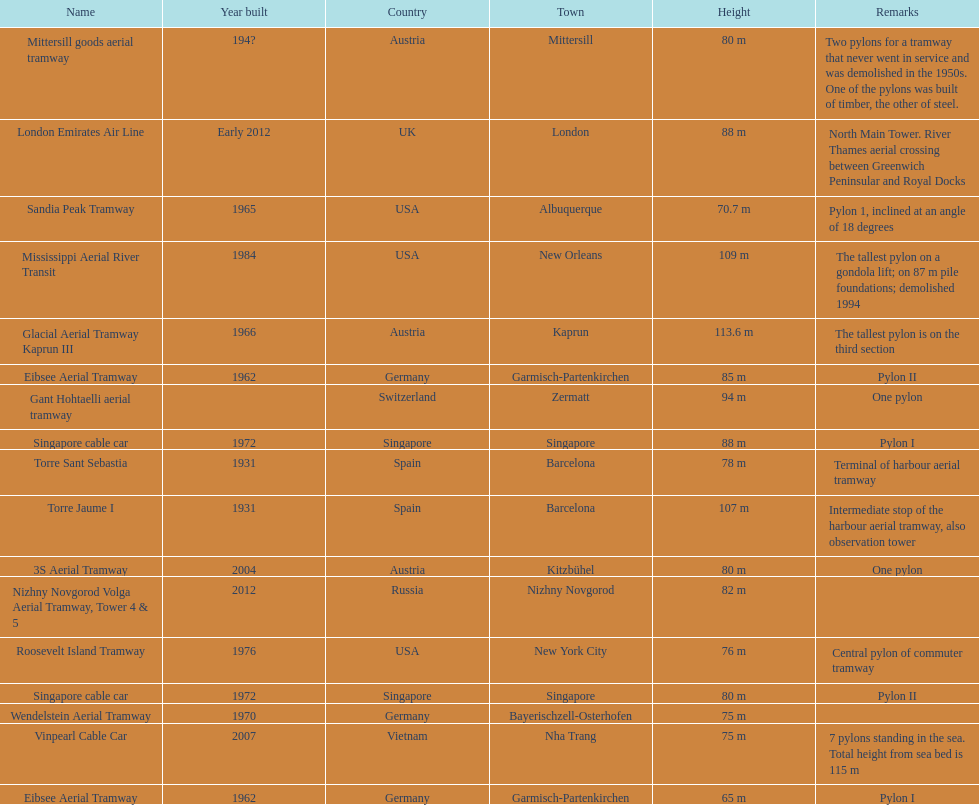The london emirates air line pylon has the same height as which pylon? Singapore cable car. 